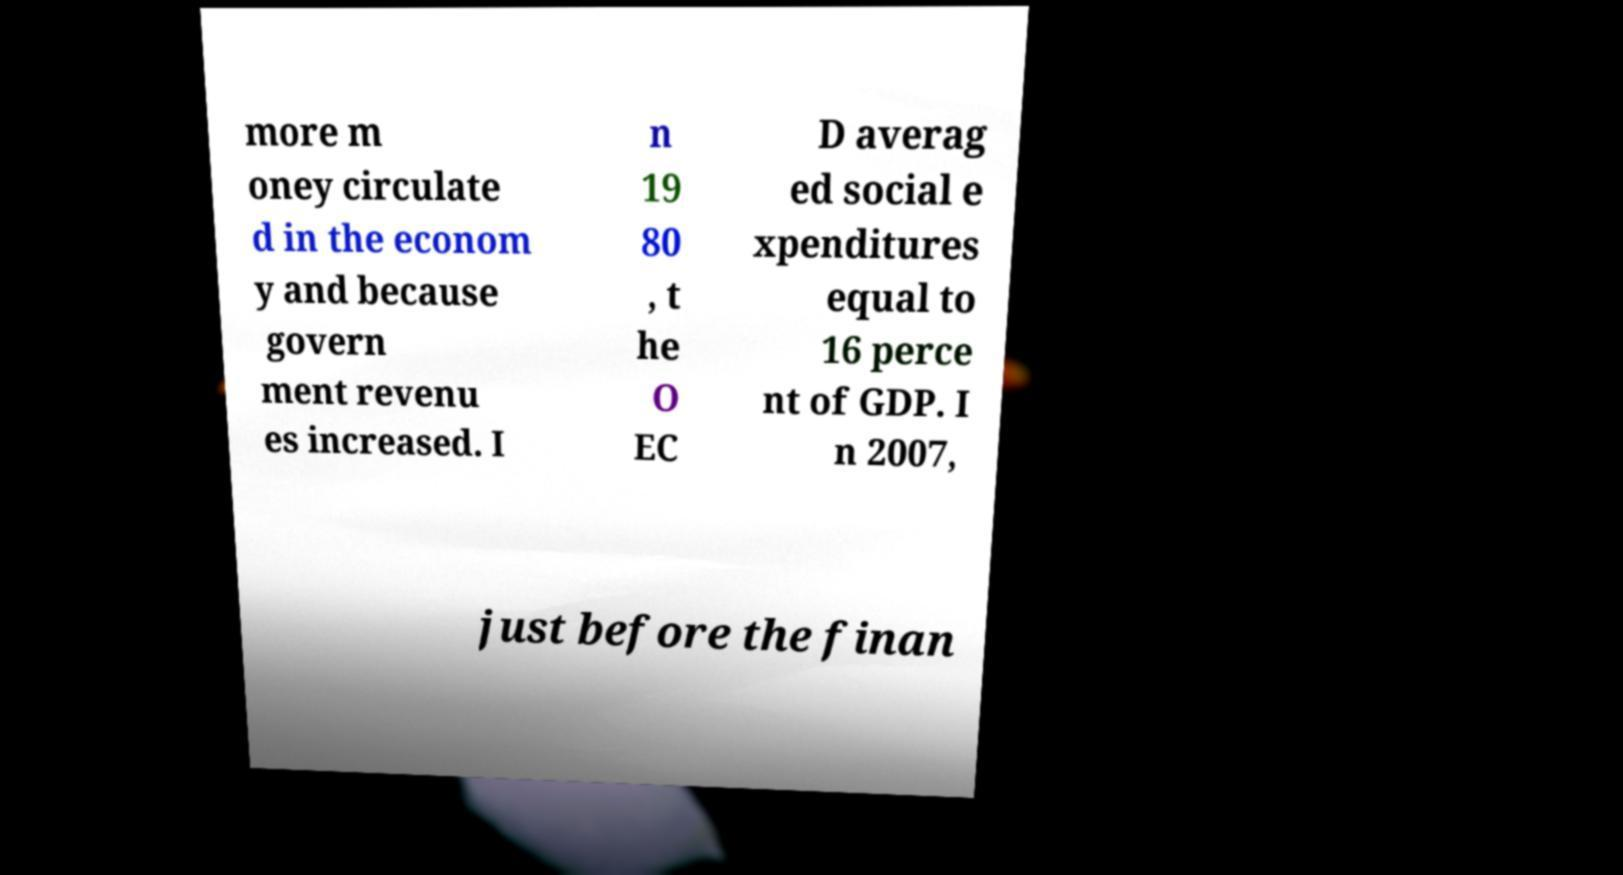Can you read and provide the text displayed in the image?This photo seems to have some interesting text. Can you extract and type it out for me? more m oney circulate d in the econom y and because govern ment revenu es increased. I n 19 80 , t he O EC D averag ed social e xpenditures equal to 16 perce nt of GDP. I n 2007, just before the finan 